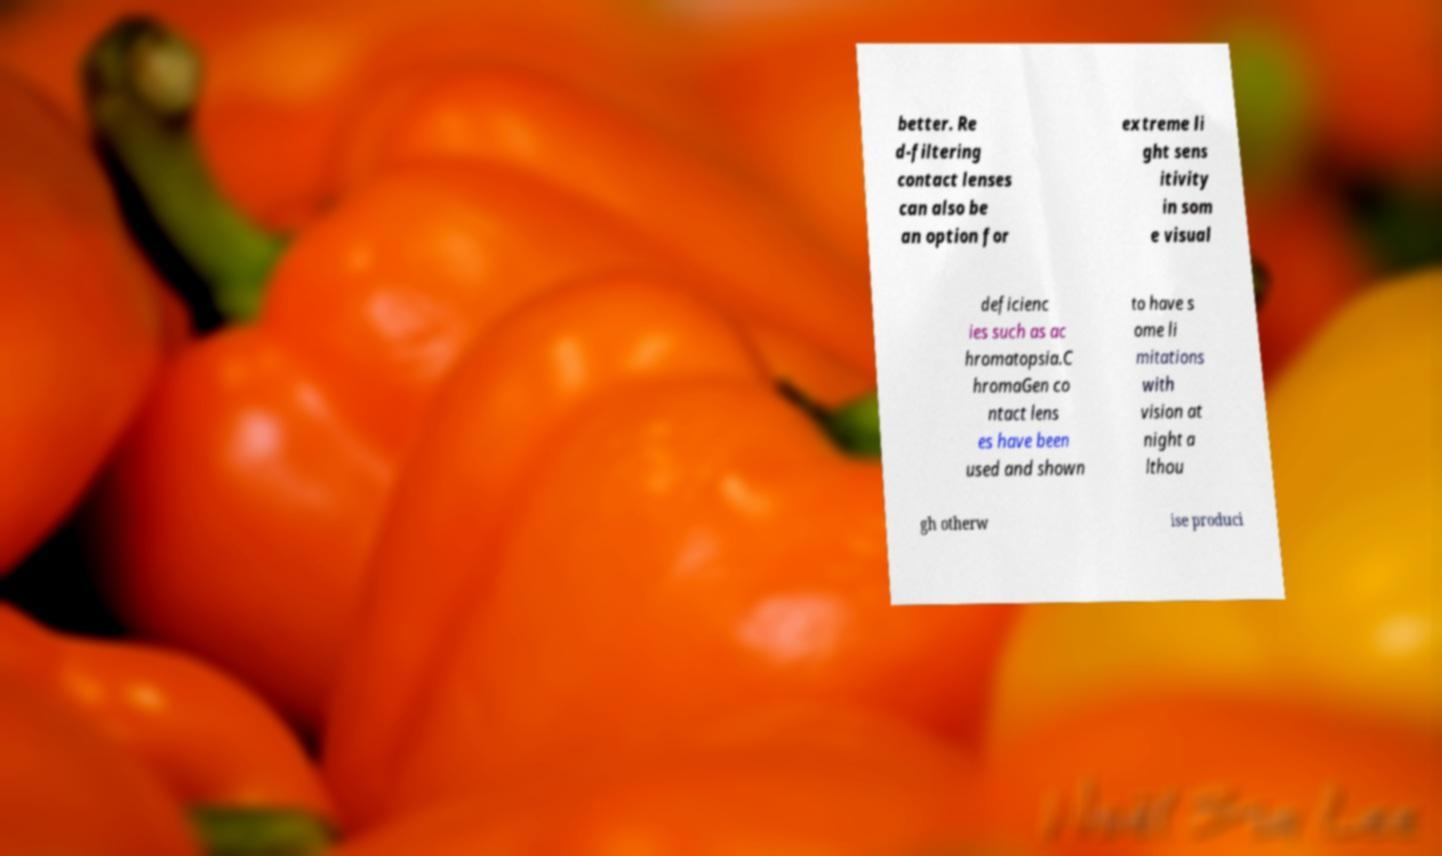For documentation purposes, I need the text within this image transcribed. Could you provide that? better. Re d-filtering contact lenses can also be an option for extreme li ght sens itivity in som e visual deficienc ies such as ac hromatopsia.C hromaGen co ntact lens es have been used and shown to have s ome li mitations with vision at night a lthou gh otherw ise produci 